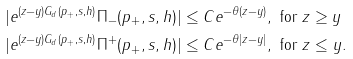<formula> <loc_0><loc_0><loc_500><loc_500>& | e ^ { ( z - y ) G _ { d } ( p _ { + } , s , h ) } \Pi _ { - } ( p _ { + } , s , h ) | \leq C e ^ { - \theta ( z - y ) } , \text { for } z \geq y \\ & | e ^ { ( z - y ) G _ { d } ( p _ { + } , s , h ) } \Pi ^ { + } ( p _ { + } , s , h ) | \leq C e ^ { - \theta | z - y | } , \text { for } z \leq y .</formula> 